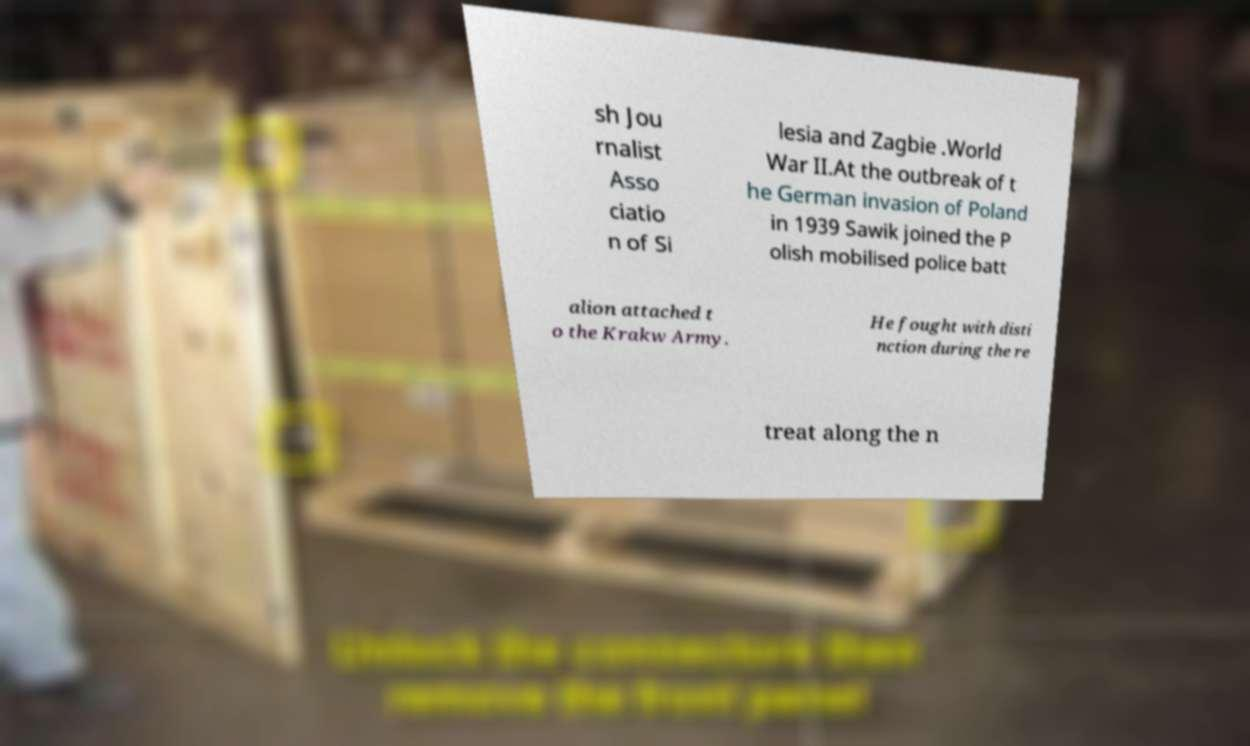Please read and relay the text visible in this image. What does it say? sh Jou rnalist Asso ciatio n of Si lesia and Zagbie .World War II.At the outbreak of t he German invasion of Poland in 1939 Sawik joined the P olish mobilised police batt alion attached t o the Krakw Army. He fought with disti nction during the re treat along the n 